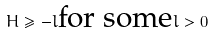Convert formula to latex. <formula><loc_0><loc_0><loc_500><loc_500>H \geq - l \text {for some} l > 0</formula> 